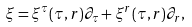Convert formula to latex. <formula><loc_0><loc_0><loc_500><loc_500>\xi = \xi ^ { \tau } ( \tau , r ) \partial _ { \tau } + \xi ^ { r } ( \tau , r ) \partial _ { r } ,</formula> 